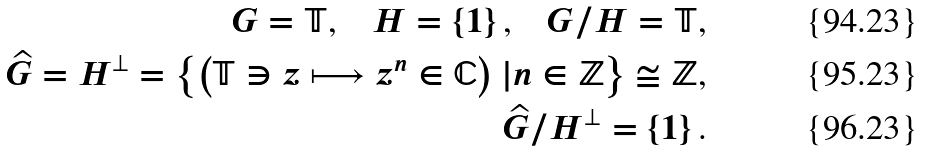<formula> <loc_0><loc_0><loc_500><loc_500>G = \mathbb { T } \text {,\quad } H = \left \{ 1 \right \} \text {,\quad } G / H = \mathbb { T } \text {,} \\ \widehat { G } = H ^ { \perp } = \left \{ \left ( \mathbb { T } \ni z \longmapsto z ^ { n } \in \mathbb { C } \right ) | n \in \mathbb { Z } \right \} \cong \mathbb { Z } \text {,} \\ \widehat { G } / H ^ { \perp } = \left \{ 1 \right \} \text {.}</formula> 